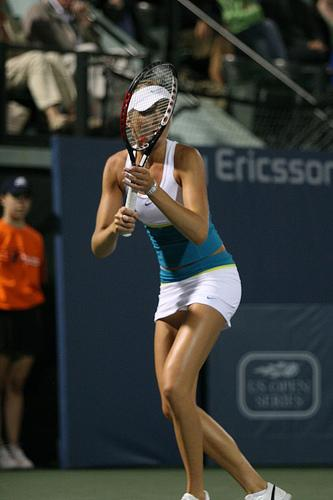Report the key figure presented in the image and their existing engagement. A committed woman dressed in a Nike tennis attire is involved in a tennis game, holding a multi-colored racquet. Explain who is the primary character in the scene and what they are doing. A determined woman in a tennis attire from Nike is playing tennis and holding a vivid racquet. Identify the primary focus of the image and share their current activity. A female tennis player is concentrating on her game while holding a modern red, black, and white tennis racquet. Point out the central figure in the image and describe what they are engaged in. A woman wearing a tennis outfit by Nike is in the middle of a tennis match, holding a racket and concentrating. Mention the most prominent object in the picture and the action taking place. A woman playing tennis is holding a colorful racquet and seems focused on her game. Outline the chief personage depicted in the image and the corresponding occurrence. An intense female adorned in a Nike tennis outfit is participating in a tennis contest, gripping a vibrant racquet. Portray the principal personality in the photo and the ongoing action. A focused female tennis player, sporting a Nike ensemble, is engaged in a gripping match while holding an eye-catching racquet. Elaborate on the main protagonist in the picture and their current undertaking. A resolute woman, sporting a tennis outfit by Nike, is immersed in a tennis match while brandishing a colorful racket. Recount the central individual in the photograph and their present venture. A devoted lady clad in Nike tennis gear is engaged in a game of tennis, wielding a striking racquet. State the main subject present in the image and the ongoing event. The image features a female tennis player, who is deeply focused on her match while holding a racquet. 